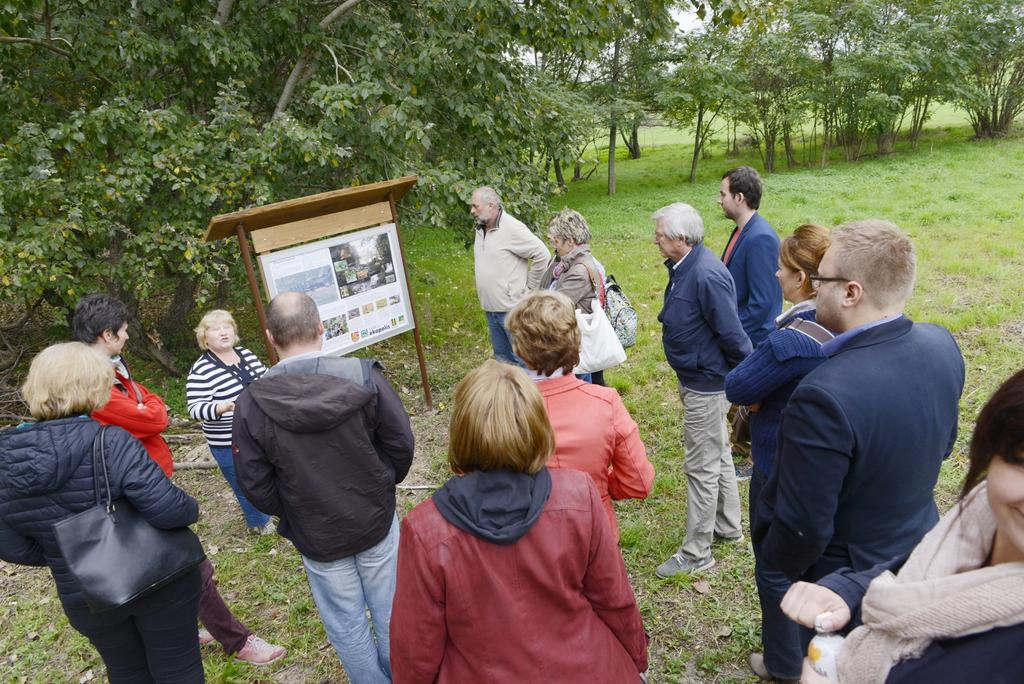What are the people in the image doing? The group of people is standing on the ground in the image. What objects can be seen in the image besides the people? There is a board and a pole in the image. What type of terrain is visible in the image? There is grass in the image, suggesting that the terrain is grassy. What type of vegetation is present in the image? There are trees in the image. What type of quince can be seen growing on the pole in the image? There is no quince present in the image, and the pole does not have any plants growing on it. 